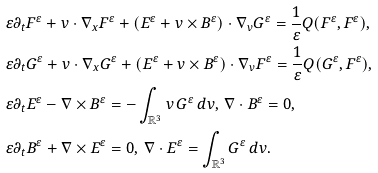<formula> <loc_0><loc_0><loc_500><loc_500>& \varepsilon \partial _ { t } F ^ { \varepsilon } + v \cdot \nabla _ { x } F ^ { \varepsilon } + ( E ^ { \varepsilon } + v \times B ^ { \varepsilon } ) \cdot \nabla _ { v } G ^ { \varepsilon } = \frac { 1 } { \varepsilon } Q ( F ^ { \varepsilon } , F ^ { \varepsilon } ) , \\ & \varepsilon \partial _ { t } G ^ { \varepsilon } + v \cdot \nabla _ { x } G ^ { \varepsilon } + ( E ^ { \varepsilon } + v \times B ^ { \varepsilon } ) \cdot \nabla _ { v } F ^ { \varepsilon } = \frac { 1 } { \varepsilon } Q ( G ^ { \varepsilon } , F ^ { \varepsilon } ) , \\ & \varepsilon \partial _ { t } E ^ { \varepsilon } - \nabla \times B ^ { \varepsilon } = - \int _ { { \mathbb { R } } ^ { 3 } } v \, G ^ { \varepsilon } \, d v , \, \nabla \cdot B ^ { \varepsilon } = 0 , \\ & \varepsilon \partial _ { t } B ^ { \varepsilon } + \nabla \times E ^ { \varepsilon } = 0 , \, \nabla \cdot E ^ { \varepsilon } = \int _ { { \mathbb { R } } ^ { 3 } } G ^ { \varepsilon } \, d v .</formula> 